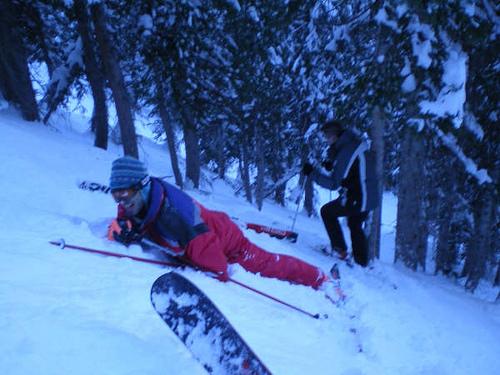Did one skier fall?
Short answer required. Yes. What is the person doing?
Quick response, please. Falling. Is he using a snowboard or skis?
Be succinct. Skis. Is this person athletic?
Answer briefly. No. Is the person sitting in the snow?
Be succinct. No. Does she look like she fell or sitting?
Answer briefly. Fell. Was this picture taken at night?
Concise answer only. No. How fast is the skier in the red pants going?
Be succinct. Slow. Why are most of the kids sitting?
Answer briefly. They fell. What color is the snow under the snowboarder?
Keep it brief. White. Is this man on both knees in the snow?
Concise answer only. Yes. What color are the man's pants?
Concise answer only. Red. Is this person injured?
Quick response, please. No. Does the fallen skier look angry?
Be succinct. No. 